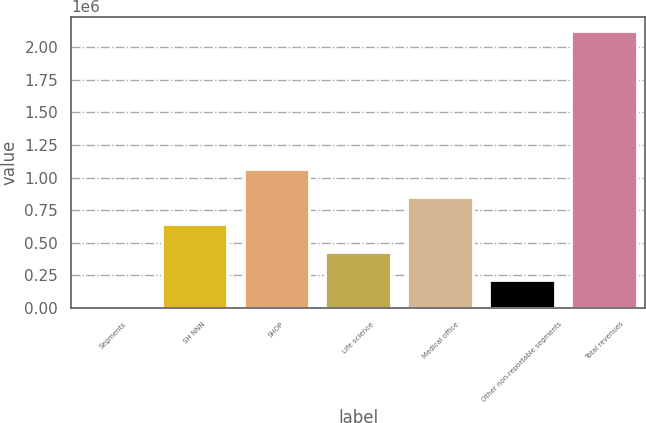Convert chart to OTSL. <chart><loc_0><loc_0><loc_500><loc_500><bar_chart><fcel>Segments<fcel>SH NNN<fcel>SHOP<fcel>Life science<fcel>Medical office<fcel>Other non-reportable segments<fcel>Total revenues<nl><fcel>2016<fcel>640199<fcel>1.06566e+06<fcel>427472<fcel>852927<fcel>214744<fcel>2.12929e+06<nl></chart> 